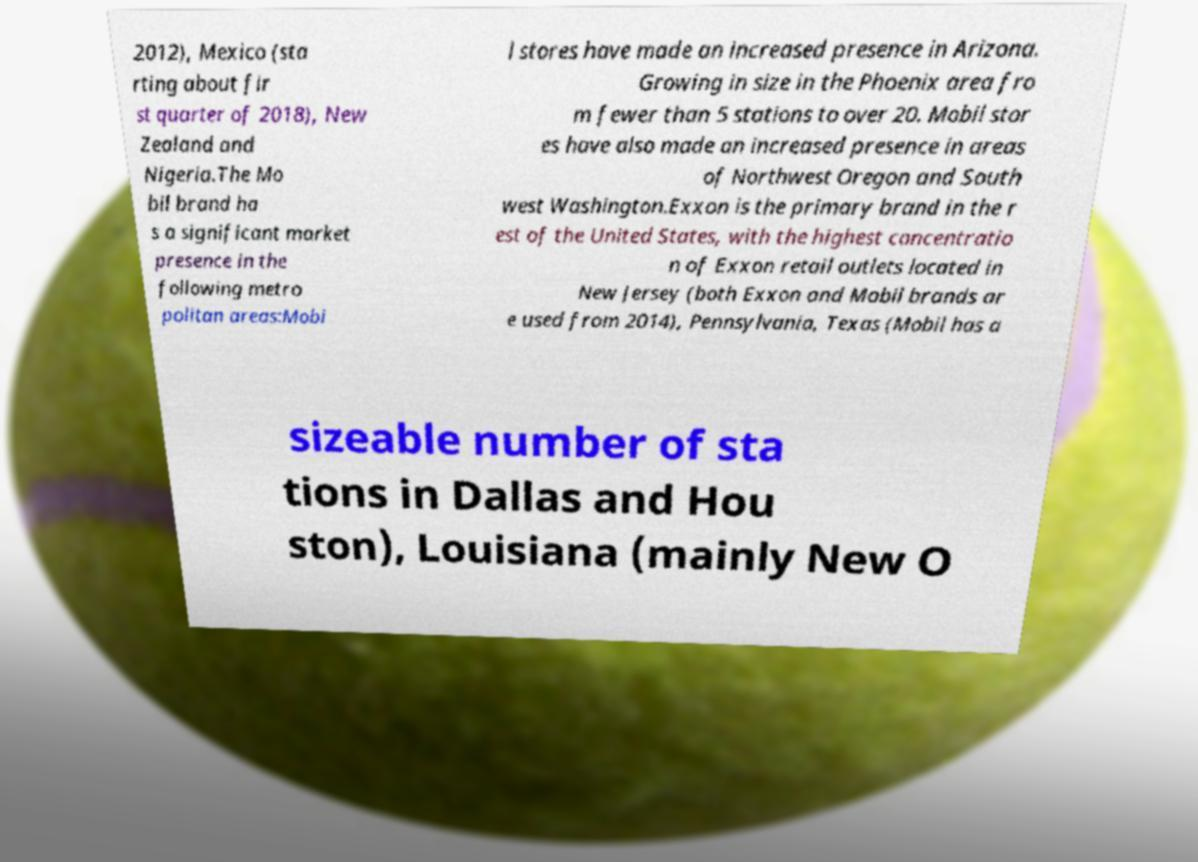For documentation purposes, I need the text within this image transcribed. Could you provide that? 2012), Mexico (sta rting about fir st quarter of 2018), New Zealand and Nigeria.The Mo bil brand ha s a significant market presence in the following metro politan areas:Mobi l stores have made an increased presence in Arizona. Growing in size in the Phoenix area fro m fewer than 5 stations to over 20. Mobil stor es have also made an increased presence in areas of Northwest Oregon and South west Washington.Exxon is the primary brand in the r est of the United States, with the highest concentratio n of Exxon retail outlets located in New Jersey (both Exxon and Mobil brands ar e used from 2014), Pennsylvania, Texas (Mobil has a sizeable number of sta tions in Dallas and Hou ston), Louisiana (mainly New O 